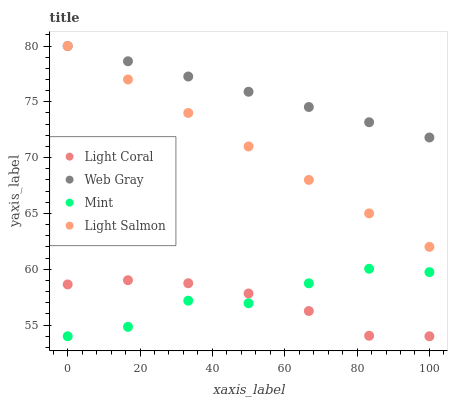Does Light Coral have the minimum area under the curve?
Answer yes or no. Yes. Does Web Gray have the maximum area under the curve?
Answer yes or no. Yes. Does Light Salmon have the minimum area under the curve?
Answer yes or no. No. Does Light Salmon have the maximum area under the curve?
Answer yes or no. No. Is Web Gray the smoothest?
Answer yes or no. Yes. Is Mint the roughest?
Answer yes or no. Yes. Is Light Salmon the smoothest?
Answer yes or no. No. Is Light Salmon the roughest?
Answer yes or no. No. Does Light Coral have the lowest value?
Answer yes or no. Yes. Does Light Salmon have the lowest value?
Answer yes or no. No. Does Web Gray have the highest value?
Answer yes or no. Yes. Does Mint have the highest value?
Answer yes or no. No. Is Mint less than Web Gray?
Answer yes or no. Yes. Is Light Salmon greater than Light Coral?
Answer yes or no. Yes. Does Light Salmon intersect Web Gray?
Answer yes or no. Yes. Is Light Salmon less than Web Gray?
Answer yes or no. No. Is Light Salmon greater than Web Gray?
Answer yes or no. No. Does Mint intersect Web Gray?
Answer yes or no. No. 